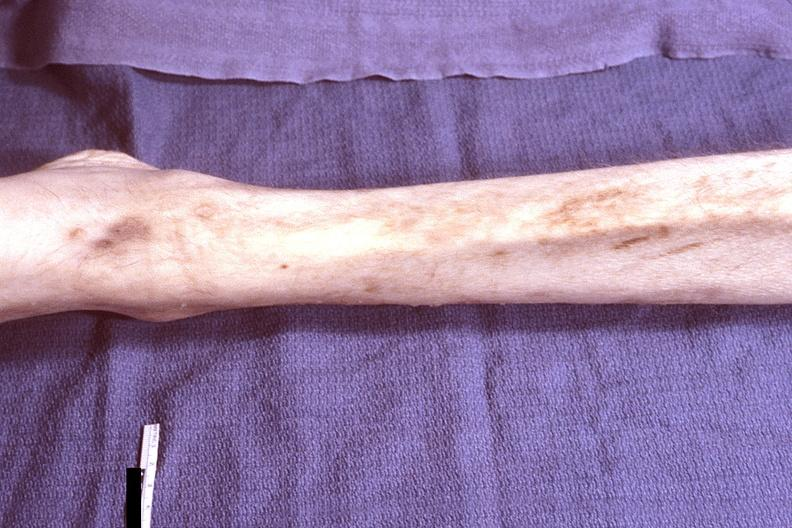does this image show leg - muscle wasting, hiv?
Answer the question using a single word or phrase. Yes 